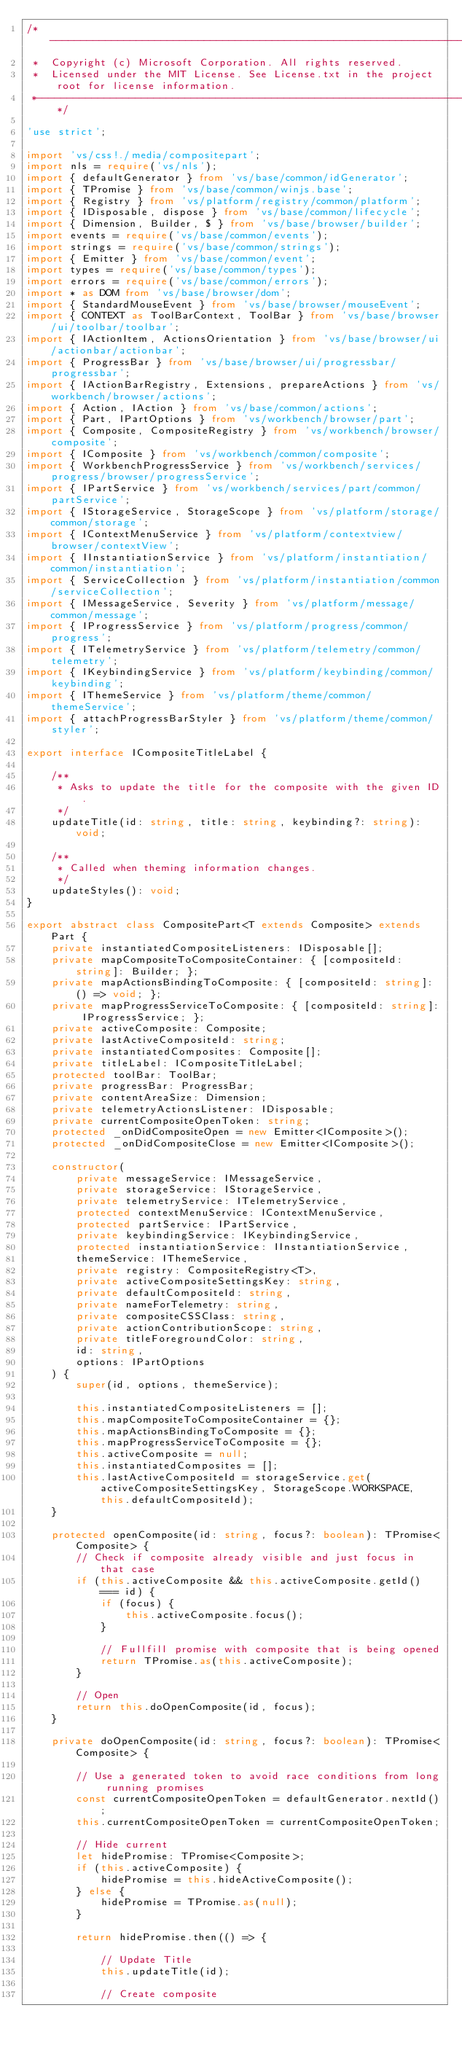<code> <loc_0><loc_0><loc_500><loc_500><_TypeScript_>/*---------------------------------------------------------------------------------------------
 *  Copyright (c) Microsoft Corporation. All rights reserved.
 *  Licensed under the MIT License. See License.txt in the project root for license information.
 *--------------------------------------------------------------------------------------------*/

'use strict';

import 'vs/css!./media/compositepart';
import nls = require('vs/nls');
import { defaultGenerator } from 'vs/base/common/idGenerator';
import { TPromise } from 'vs/base/common/winjs.base';
import { Registry } from 'vs/platform/registry/common/platform';
import { IDisposable, dispose } from 'vs/base/common/lifecycle';
import { Dimension, Builder, $ } from 'vs/base/browser/builder';
import events = require('vs/base/common/events');
import strings = require('vs/base/common/strings');
import { Emitter } from 'vs/base/common/event';
import types = require('vs/base/common/types');
import errors = require('vs/base/common/errors');
import * as DOM from 'vs/base/browser/dom';
import { StandardMouseEvent } from 'vs/base/browser/mouseEvent';
import { CONTEXT as ToolBarContext, ToolBar } from 'vs/base/browser/ui/toolbar/toolbar';
import { IActionItem, ActionsOrientation } from 'vs/base/browser/ui/actionbar/actionbar';
import { ProgressBar } from 'vs/base/browser/ui/progressbar/progressbar';
import { IActionBarRegistry, Extensions, prepareActions } from 'vs/workbench/browser/actions';
import { Action, IAction } from 'vs/base/common/actions';
import { Part, IPartOptions } from 'vs/workbench/browser/part';
import { Composite, CompositeRegistry } from 'vs/workbench/browser/composite';
import { IComposite } from 'vs/workbench/common/composite';
import { WorkbenchProgressService } from 'vs/workbench/services/progress/browser/progressService';
import { IPartService } from 'vs/workbench/services/part/common/partService';
import { IStorageService, StorageScope } from 'vs/platform/storage/common/storage';
import { IContextMenuService } from 'vs/platform/contextview/browser/contextView';
import { IInstantiationService } from 'vs/platform/instantiation/common/instantiation';
import { ServiceCollection } from 'vs/platform/instantiation/common/serviceCollection';
import { IMessageService, Severity } from 'vs/platform/message/common/message';
import { IProgressService } from 'vs/platform/progress/common/progress';
import { ITelemetryService } from 'vs/platform/telemetry/common/telemetry';
import { IKeybindingService } from 'vs/platform/keybinding/common/keybinding';
import { IThemeService } from 'vs/platform/theme/common/themeService';
import { attachProgressBarStyler } from 'vs/platform/theme/common/styler';

export interface ICompositeTitleLabel {

	/**
	 * Asks to update the title for the composite with the given ID.
	 */
	updateTitle(id: string, title: string, keybinding?: string): void;

	/**
	 * Called when theming information changes.
	 */
	updateStyles(): void;
}

export abstract class CompositePart<T extends Composite> extends Part {
	private instantiatedCompositeListeners: IDisposable[];
	private mapCompositeToCompositeContainer: { [compositeId: string]: Builder; };
	private mapActionsBindingToComposite: { [compositeId: string]: () => void; };
	private mapProgressServiceToComposite: { [compositeId: string]: IProgressService; };
	private activeComposite: Composite;
	private lastActiveCompositeId: string;
	private instantiatedComposites: Composite[];
	private titleLabel: ICompositeTitleLabel;
	protected toolBar: ToolBar;
	private progressBar: ProgressBar;
	private contentAreaSize: Dimension;
	private telemetryActionsListener: IDisposable;
	private currentCompositeOpenToken: string;
	protected _onDidCompositeOpen = new Emitter<IComposite>();
	protected _onDidCompositeClose = new Emitter<IComposite>();

	constructor(
		private messageService: IMessageService,
		private storageService: IStorageService,
		private telemetryService: ITelemetryService,
		protected contextMenuService: IContextMenuService,
		protected partService: IPartService,
		private keybindingService: IKeybindingService,
		protected instantiationService: IInstantiationService,
		themeService: IThemeService,
		private registry: CompositeRegistry<T>,
		private activeCompositeSettingsKey: string,
		private defaultCompositeId: string,
		private nameForTelemetry: string,
		private compositeCSSClass: string,
		private actionContributionScope: string,
		private titleForegroundColor: string,
		id: string,
		options: IPartOptions
	) {
		super(id, options, themeService);

		this.instantiatedCompositeListeners = [];
		this.mapCompositeToCompositeContainer = {};
		this.mapActionsBindingToComposite = {};
		this.mapProgressServiceToComposite = {};
		this.activeComposite = null;
		this.instantiatedComposites = [];
		this.lastActiveCompositeId = storageService.get(activeCompositeSettingsKey, StorageScope.WORKSPACE, this.defaultCompositeId);
	}

	protected openComposite(id: string, focus?: boolean): TPromise<Composite> {
		// Check if composite already visible and just focus in that case
		if (this.activeComposite && this.activeComposite.getId() === id) {
			if (focus) {
				this.activeComposite.focus();
			}

			// Fullfill promise with composite that is being opened
			return TPromise.as(this.activeComposite);
		}

		// Open
		return this.doOpenComposite(id, focus);
	}

	private doOpenComposite(id: string, focus?: boolean): TPromise<Composite> {

		// Use a generated token to avoid race conditions from long running promises
		const currentCompositeOpenToken = defaultGenerator.nextId();
		this.currentCompositeOpenToken = currentCompositeOpenToken;

		// Hide current
		let hidePromise: TPromise<Composite>;
		if (this.activeComposite) {
			hidePromise = this.hideActiveComposite();
		} else {
			hidePromise = TPromise.as(null);
		}

		return hidePromise.then(() => {

			// Update Title
			this.updateTitle(id);

			// Create composite</code> 